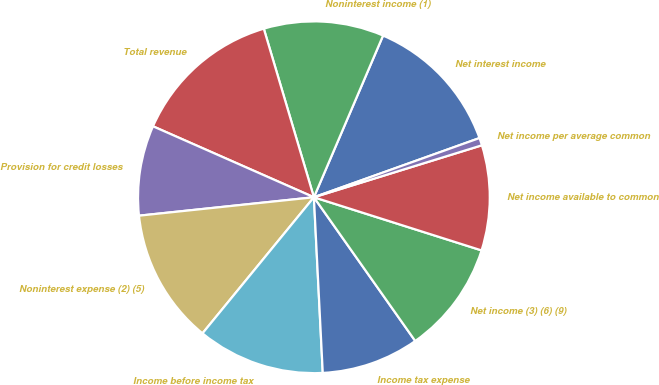Convert chart to OTSL. <chart><loc_0><loc_0><loc_500><loc_500><pie_chart><fcel>Net interest income<fcel>Noninterest income (1)<fcel>Total revenue<fcel>Provision for credit losses<fcel>Noninterest expense (2) (5)<fcel>Income before income tax<fcel>Income tax expense<fcel>Net income (3) (6) (9)<fcel>Net income available to common<fcel>Net income per average common<nl><fcel>13.1%<fcel>11.03%<fcel>13.79%<fcel>8.28%<fcel>12.41%<fcel>11.72%<fcel>8.97%<fcel>10.34%<fcel>9.66%<fcel>0.69%<nl></chart> 